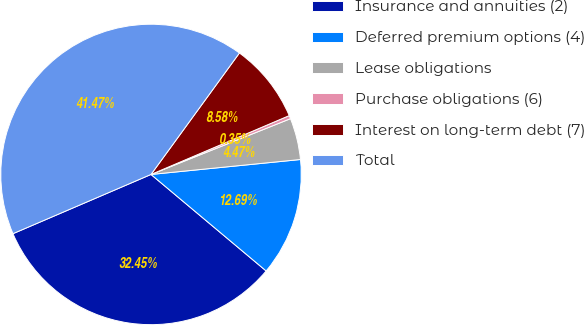Convert chart to OTSL. <chart><loc_0><loc_0><loc_500><loc_500><pie_chart><fcel>Insurance and annuities (2)<fcel>Deferred premium options (4)<fcel>Lease obligations<fcel>Purchase obligations (6)<fcel>Interest on long-term debt (7)<fcel>Total<nl><fcel>32.45%<fcel>12.69%<fcel>4.47%<fcel>0.35%<fcel>8.58%<fcel>41.47%<nl></chart> 